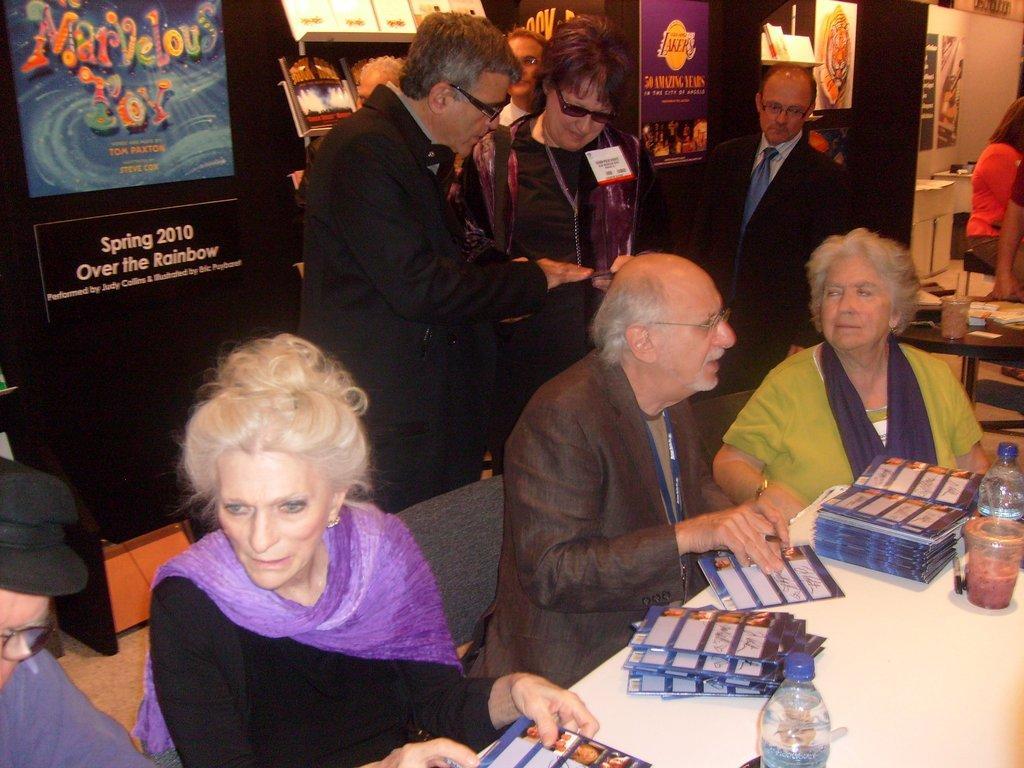Describe this image in one or two sentences. In this image I can see number of people where few are sitting on chairs and rest all are standing. I can also see most of them are wearing specs. On the right side of this image I can see two tables and on these tables I can see number of pamphlets like things, two bottles, a glass and few other stuffs. In the background I can see number of boards and on it I can see something is written. 